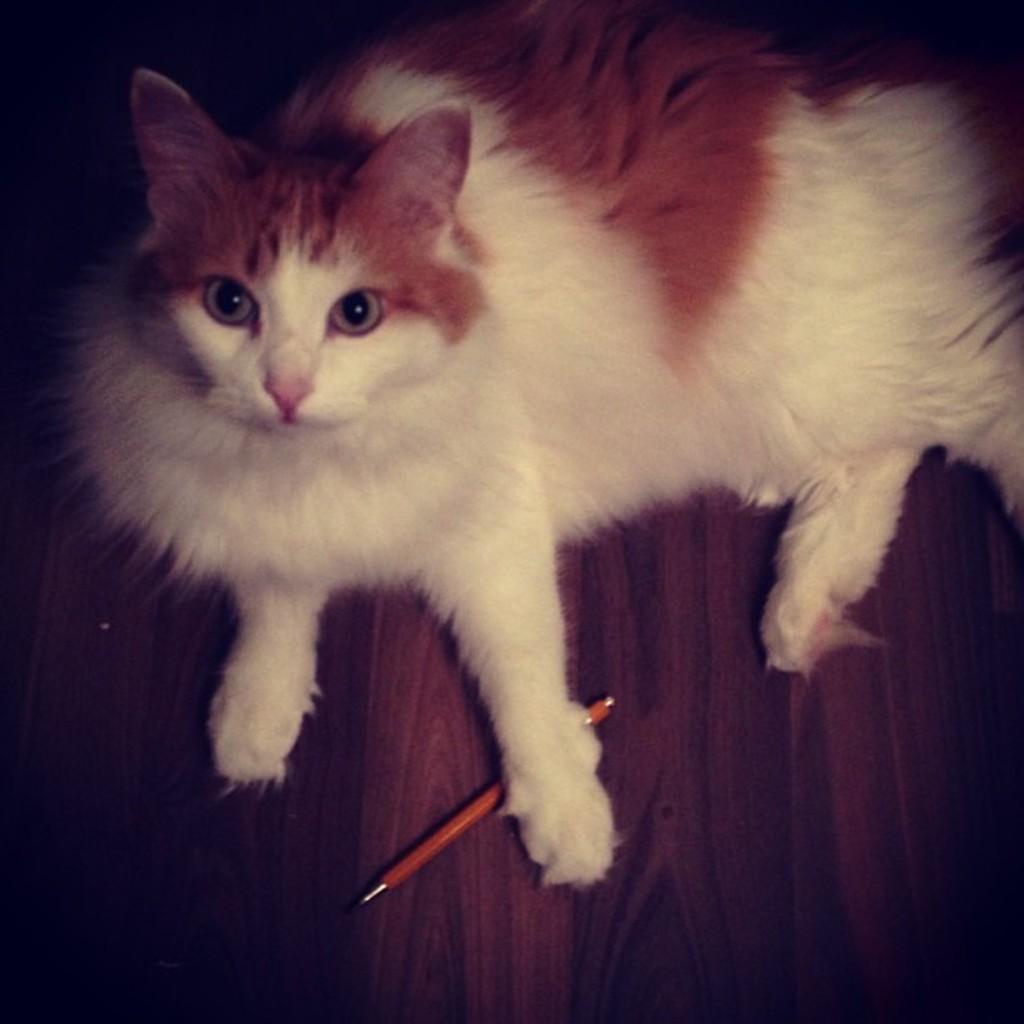Could you give a brief overview of what you see in this image? This pictures seems to be clicked inside. In the center there is a white color cat sitting on an object seems to be the table and we can see an orange color pen is placed on the top of the wooden object. 